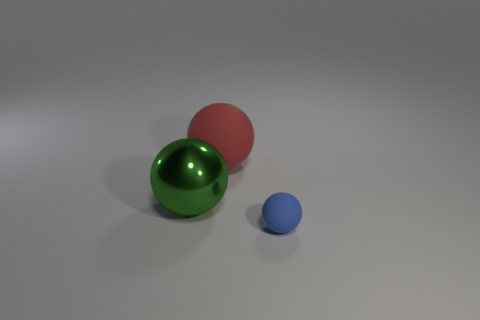Is there anything else that has the same material as the large green ball?
Provide a succinct answer. No. Is the material of the big green thing the same as the big ball that is behind the green object?
Offer a terse response. No. Are there fewer large green metallic objects than metal cubes?
Provide a short and direct response. No. There is a object that is the same material as the small blue sphere; what is its shape?
Provide a short and direct response. Sphere. There is a ball on the left side of the rubber thing that is to the left of the blue matte object; how many tiny balls are right of it?
Offer a very short reply. 1. The thing that is both on the right side of the green metal ball and on the left side of the tiny rubber object has what shape?
Keep it short and to the point. Sphere. Is the number of shiny spheres behind the red object less than the number of big gray matte cylinders?
Your answer should be compact. No. How many big things are either purple matte things or red rubber balls?
Offer a terse response. 1. What size is the metallic thing?
Ensure brevity in your answer.  Large. How many blue rubber objects are on the left side of the blue object?
Offer a very short reply. 0. 